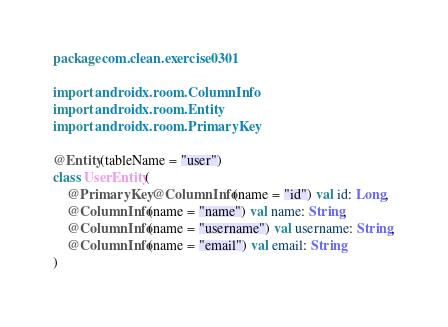Convert code to text. <code><loc_0><loc_0><loc_500><loc_500><_Kotlin_>package com.clean.exercise0301

import androidx.room.ColumnInfo
import androidx.room.Entity
import androidx.room.PrimaryKey

@Entity(tableName = "user")
class UserEntity(
    @PrimaryKey @ColumnInfo(name = "id") val id: Long,
    @ColumnInfo(name = "name") val name: String,
    @ColumnInfo(name = "username") val username: String,
    @ColumnInfo(name = "email") val email: String
)</code> 